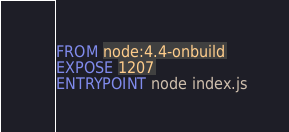Convert code to text. <code><loc_0><loc_0><loc_500><loc_500><_Dockerfile_>FROM node:4.4-onbuild
EXPOSE 1207
ENTRYPOINT node index.js</code> 